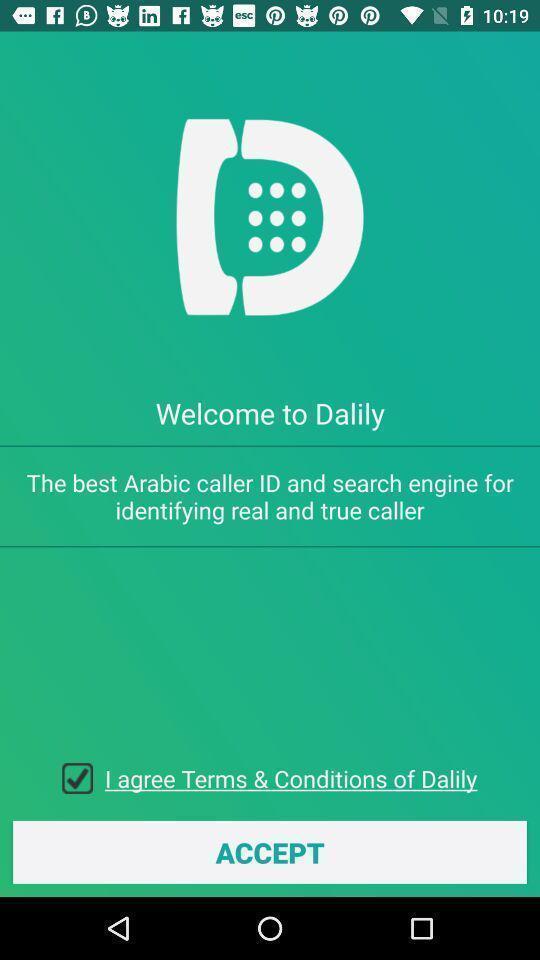What is the overall content of this screenshot? Welcome page to a true caller app. 